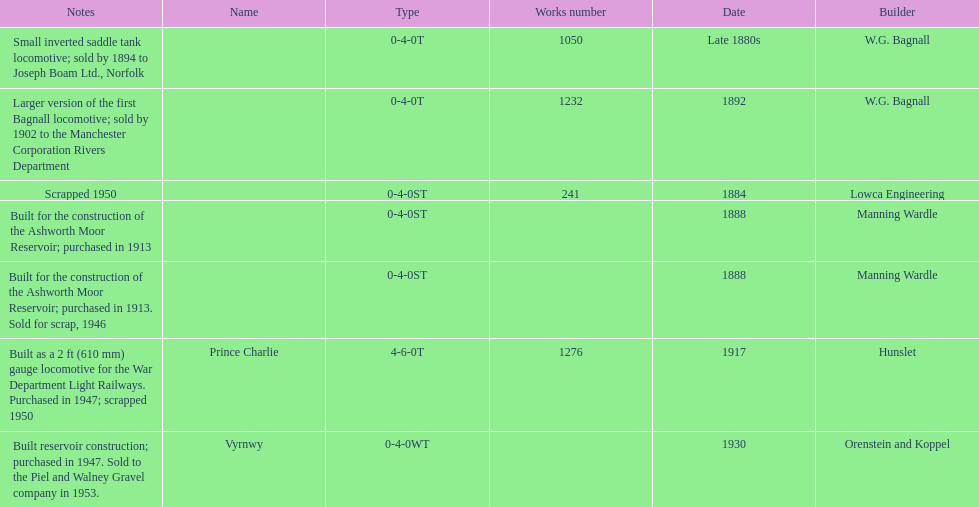What was the last locomotive? Vyrnwy. 